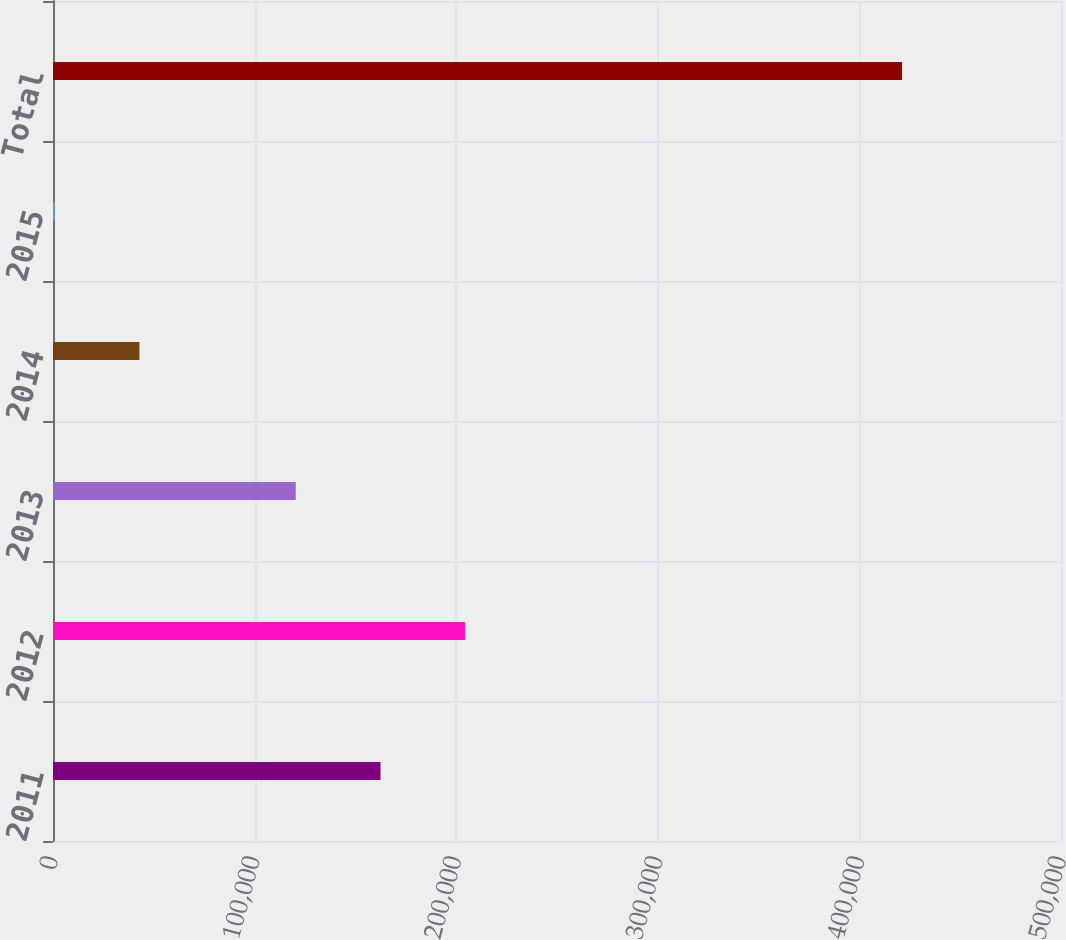<chart> <loc_0><loc_0><loc_500><loc_500><bar_chart><fcel>2011<fcel>2012<fcel>2013<fcel>2014<fcel>2015<fcel>Total<nl><fcel>162453<fcel>204482<fcel>120425<fcel>42879.3<fcel>851<fcel>421134<nl></chart> 